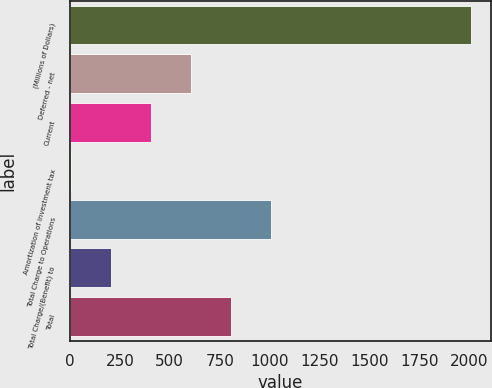Convert chart to OTSL. <chart><loc_0><loc_0><loc_500><loc_500><bar_chart><fcel>(Millions of Dollars)<fcel>Deferred - net<fcel>Current<fcel>Amortization of investment tax<fcel>Total Charge to Operations<fcel>Total Charge/(Benefit) to<fcel>Total<nl><fcel>2006<fcel>606<fcel>406<fcel>6<fcel>1006<fcel>206<fcel>806<nl></chart> 